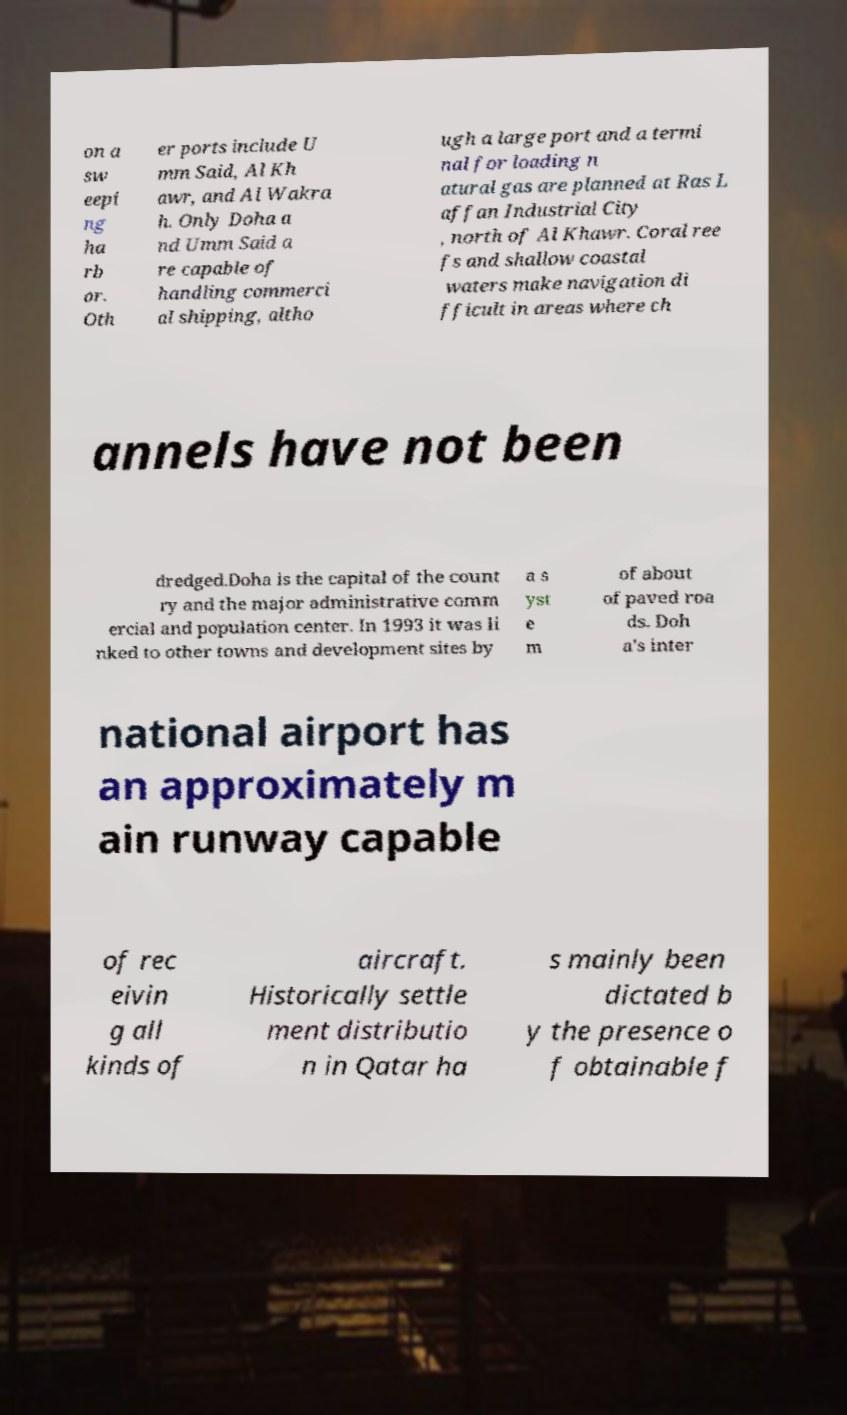Could you extract and type out the text from this image? on a sw eepi ng ha rb or. Oth er ports include U mm Said, Al Kh awr, and Al Wakra h. Only Doha a nd Umm Said a re capable of handling commerci al shipping, altho ugh a large port and a termi nal for loading n atural gas are planned at Ras L affan Industrial City , north of Al Khawr. Coral ree fs and shallow coastal waters make navigation di fficult in areas where ch annels have not been dredged.Doha is the capital of the count ry and the major administrative comm ercial and population center. In 1993 it was li nked to other towns and development sites by a s yst e m of about of paved roa ds. Doh a's inter national airport has an approximately m ain runway capable of rec eivin g all kinds of aircraft. Historically settle ment distributio n in Qatar ha s mainly been dictated b y the presence o f obtainable f 